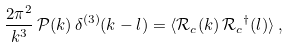<formula> <loc_0><loc_0><loc_500><loc_500>\frac { 2 \pi ^ { 2 } } { k ^ { 3 } } \, \mathcal { P } ( k ) \, \delta ^ { ( 3 ) } ( k - l ) = \langle \mathcal { R } _ { c } ( k ) \, { \mathcal { R } _ { c } } ^ { \dagger } ( l ) \rangle \, ,</formula> 